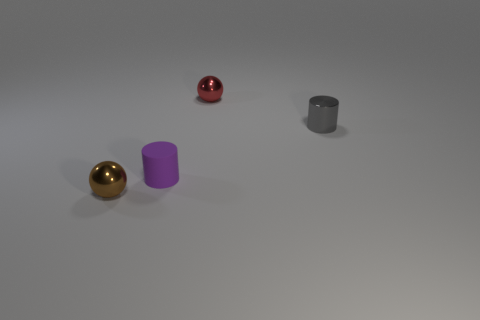Add 1 brown metal balls. How many objects exist? 5 Add 4 brown shiny things. How many brown shiny things are left? 5 Add 2 gray cylinders. How many gray cylinders exist? 3 Subtract 0 yellow spheres. How many objects are left? 4 Subtract all small brown spheres. Subtract all tiny cyan metal objects. How many objects are left? 3 